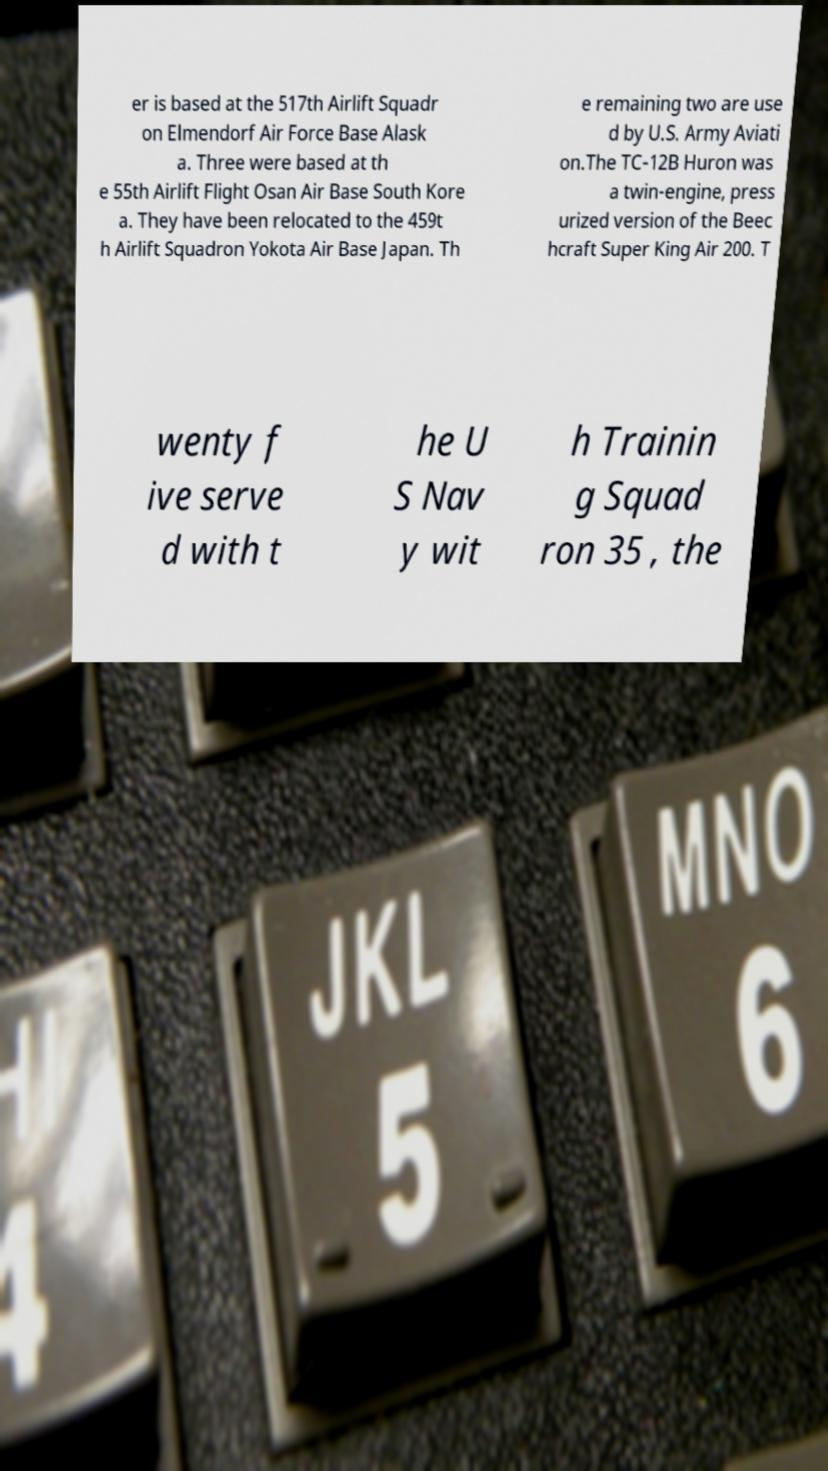Could you extract and type out the text from this image? er is based at the 517th Airlift Squadr on Elmendorf Air Force Base Alask a. Three were based at th e 55th Airlift Flight Osan Air Base South Kore a. They have been relocated to the 459t h Airlift Squadron Yokota Air Base Japan. Th e remaining two are use d by U.S. Army Aviati on.The TC-12B Huron was a twin-engine, press urized version of the Beec hcraft Super King Air 200. T wenty f ive serve d with t he U S Nav y wit h Trainin g Squad ron 35 , the 